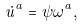Convert formula to latex. <formula><loc_0><loc_0><loc_500><loc_500>\dot { u } ^ { a } = \psi \omega ^ { a } ,</formula> 